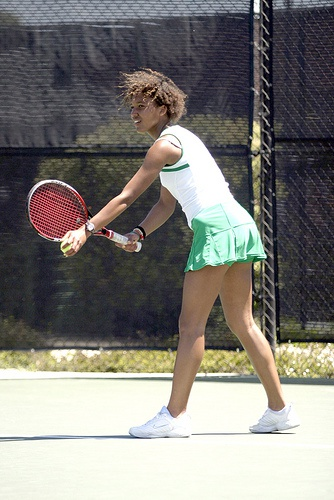Describe the objects in this image and their specific colors. I can see people in gray, white, and black tones, tennis racket in gray, salmon, maroon, black, and brown tones, and sports ball in gray, khaki, ivory, and olive tones in this image. 